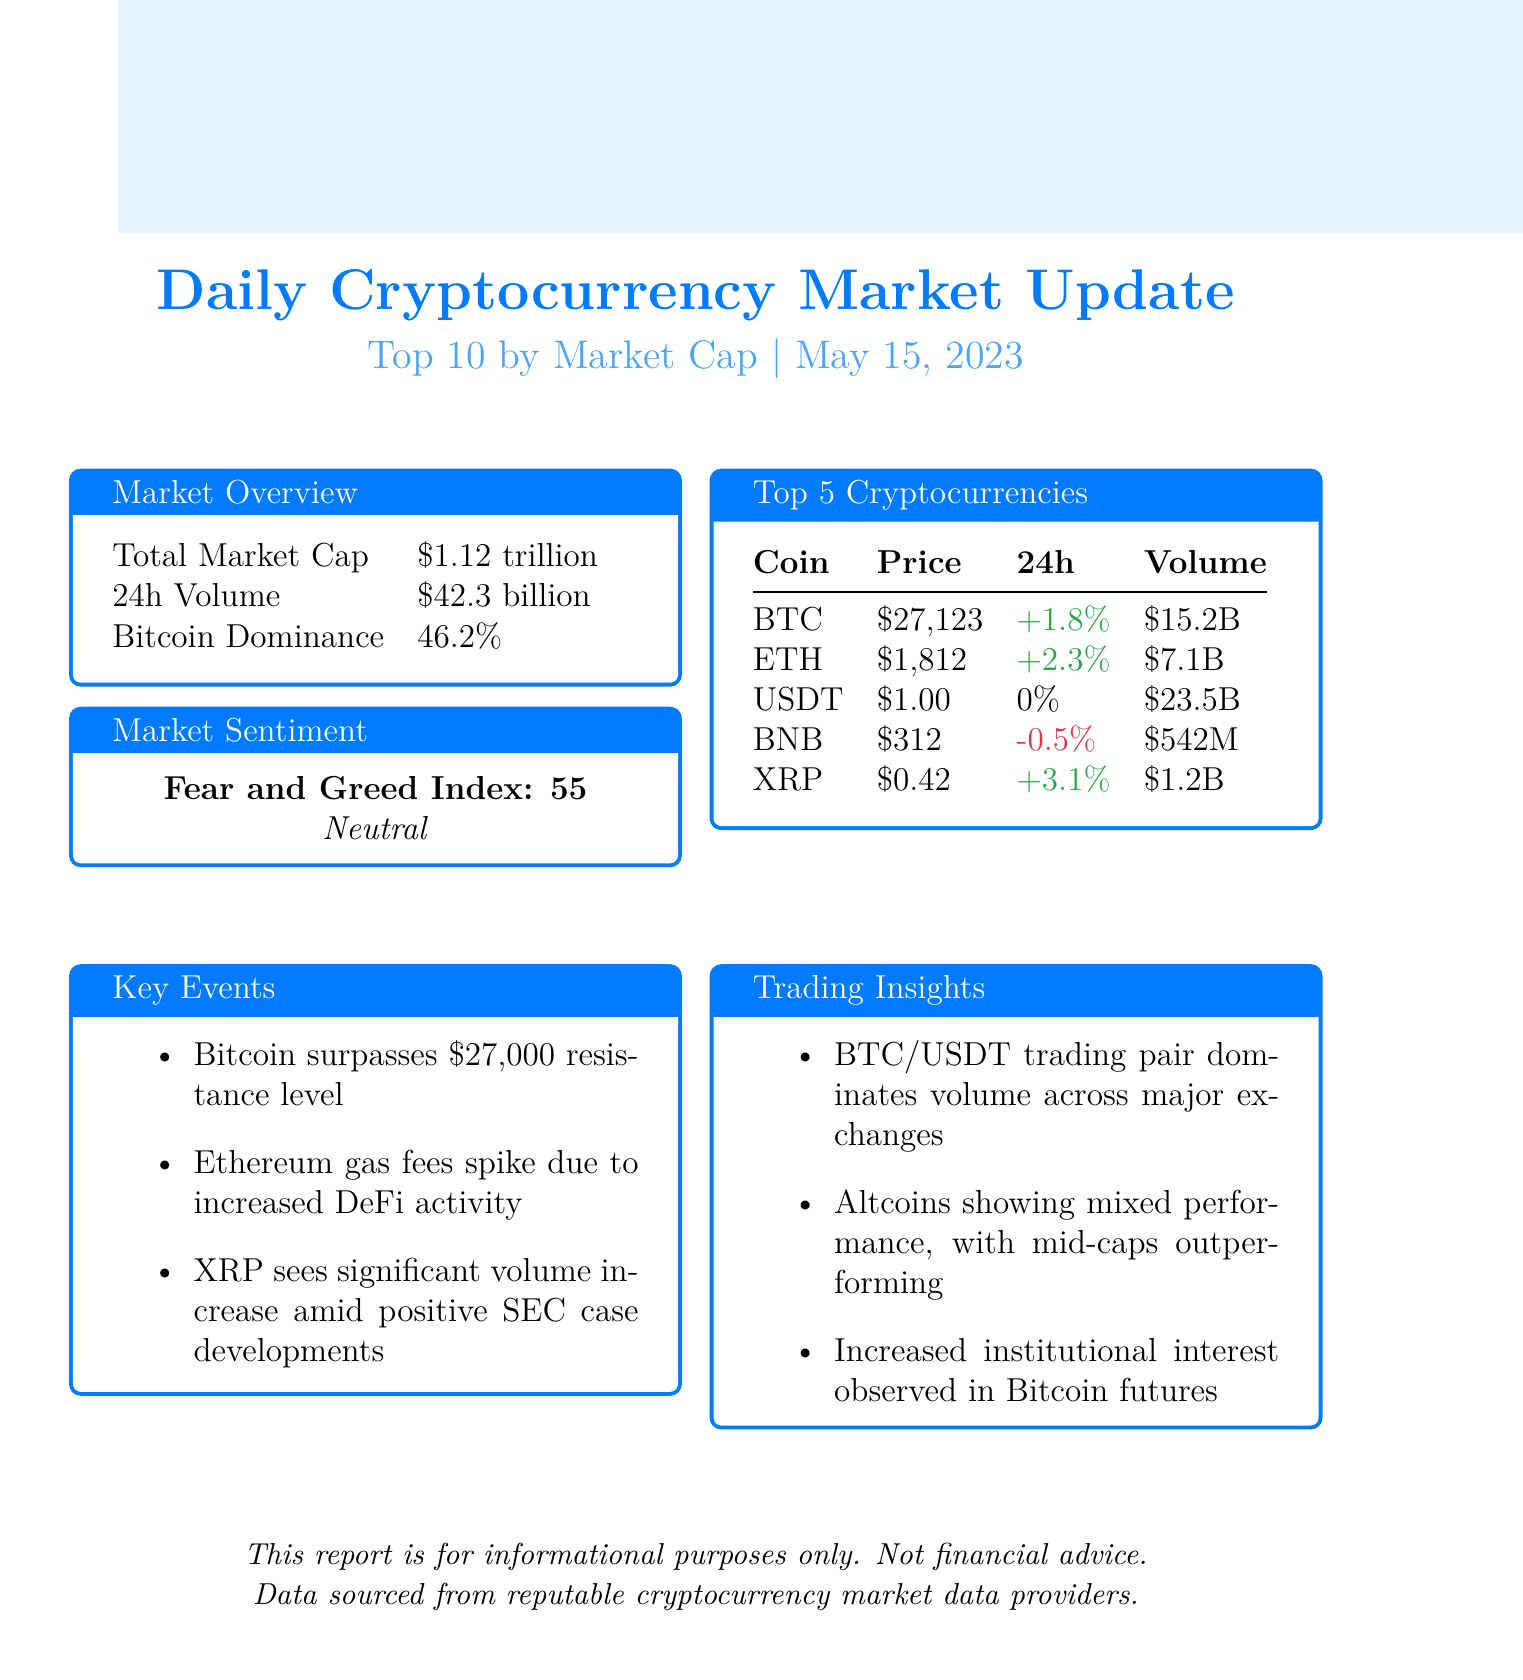What is the total market cap? The total market cap is stated in the document as $1.12 trillion.
Answer: $1.12 trillion What is the trading volume for Ethereum? The trading volume for Ethereum is provided in the top cryptocurrencies section, which is $7.1 billion.
Answer: $7.1 billion Which cryptocurrency had the highest 24-hour change? By comparing the 24-hour changes, XRP shows the highest increase at +3.1%.
Answer: XRP What is the Bitcoin dominance percentage? The document states Bitcoin dominance as 46.2%.
Answer: 46.2% What significant event occurred with Bitcoin? The key event mentioned for Bitcoin is that it surpassed $27,000 resistance level.
Answer: Surpassed $27,000 resistance level Which trading pair dominates the volume? The document notes that the BTC/USDT trading pair dominates the volume across major exchanges.
Answer: BTC/USDT What is the fear and greed index value? The fear and greed index value is stated as 55 in the market sentiment section.
Answer: 55 What was the price of Tether? The price of Tether is listed as $1.00 in the document.
Answer: $1.00 